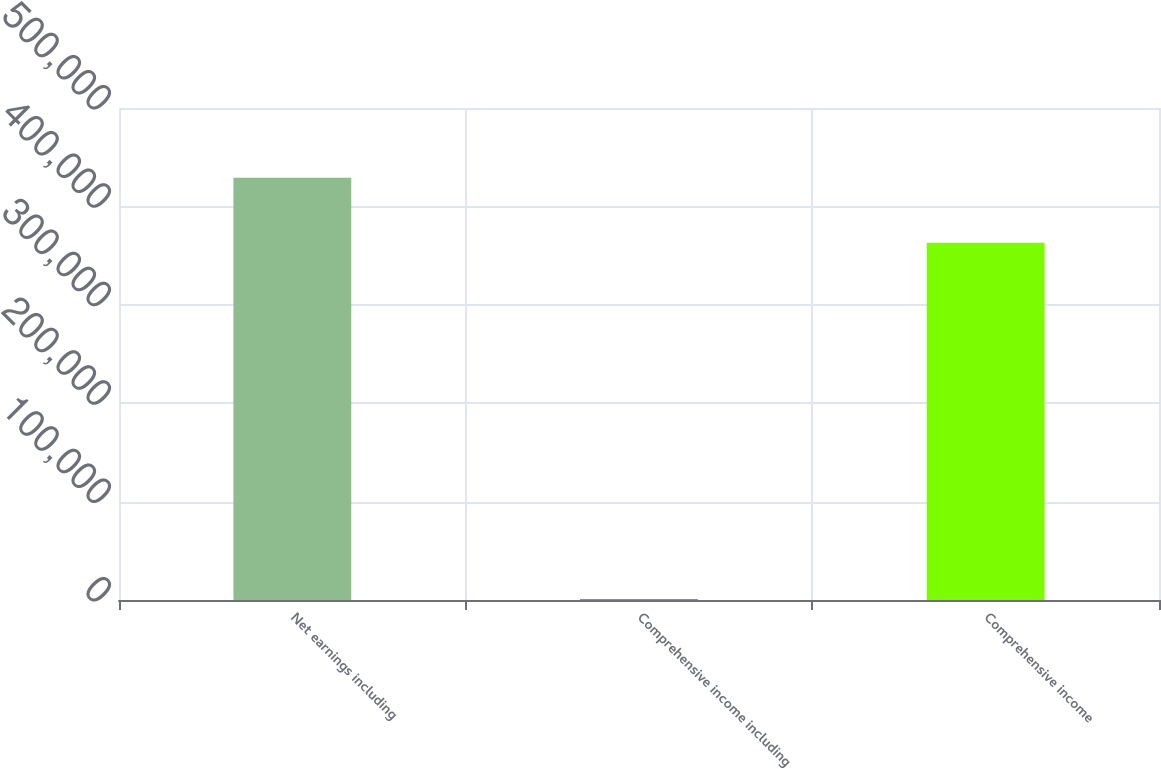Convert chart. <chart><loc_0><loc_0><loc_500><loc_500><bar_chart><fcel>Net earnings including<fcel>Comprehensive income including<fcel>Comprehensive income<nl><fcel>429231<fcel>601<fcel>362991<nl></chart> 